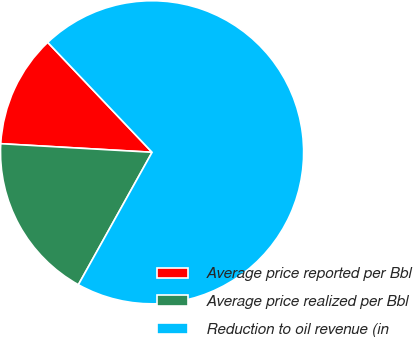<chart> <loc_0><loc_0><loc_500><loc_500><pie_chart><fcel>Average price reported per Bbl<fcel>Average price realized per Bbl<fcel>Reduction to oil revenue (in<nl><fcel>12.01%<fcel>17.82%<fcel>70.17%<nl></chart> 